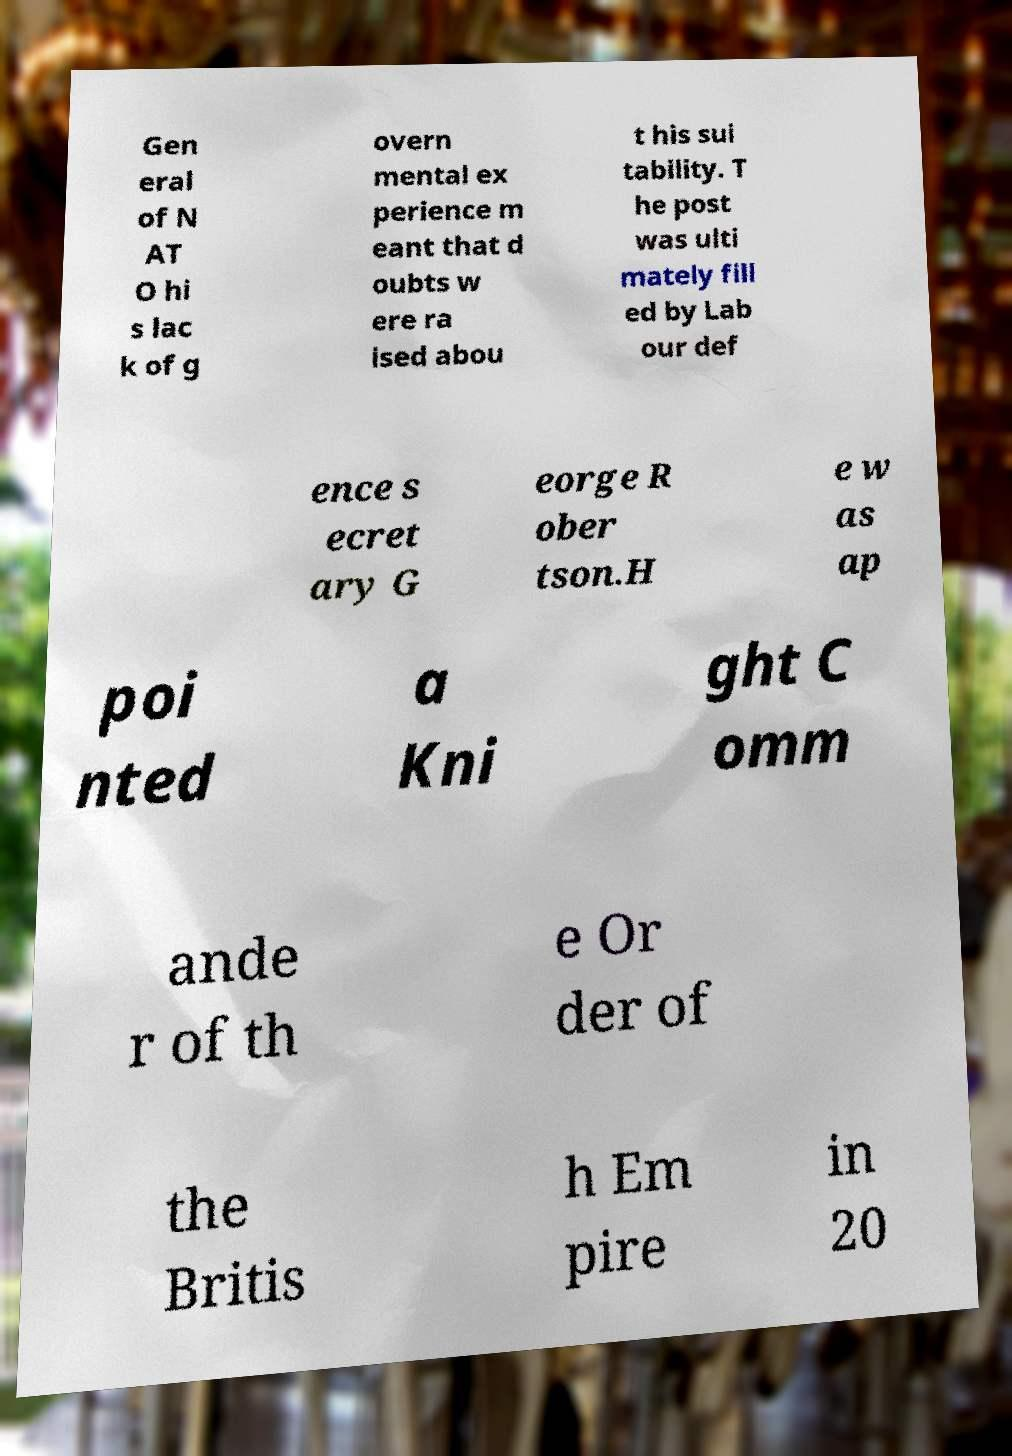Please identify and transcribe the text found in this image. Gen eral of N AT O hi s lac k of g overn mental ex perience m eant that d oubts w ere ra ised abou t his sui tability. T he post was ulti mately fill ed by Lab our def ence s ecret ary G eorge R ober tson.H e w as ap poi nted a Kni ght C omm ande r of th e Or der of the Britis h Em pire in 20 